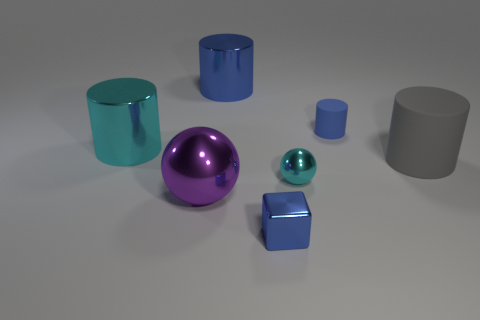There is a tiny object that is the same shape as the big blue thing; what material is it?
Your response must be concise. Rubber. What number of purple objects are in front of the cyan thing behind the gray rubber object?
Offer a very short reply. 1. Is there any other thing of the same color as the large rubber cylinder?
Your answer should be compact. No. What is the shape of the tiny cyan thing that is made of the same material as the big cyan object?
Make the answer very short. Sphere. Do the small rubber object and the small metal cube have the same color?
Provide a short and direct response. Yes. Is the small object behind the gray cylinder made of the same material as the large object in front of the large rubber cylinder?
Make the answer very short. No. How many objects are large metallic balls or large things left of the big purple metallic ball?
Provide a succinct answer. 2. Is there anything else that has the same material as the large gray thing?
Offer a very short reply. Yes. What shape is the tiny thing that is the same color as the small matte cylinder?
Your answer should be very brief. Cube. What material is the purple ball?
Provide a short and direct response. Metal. 